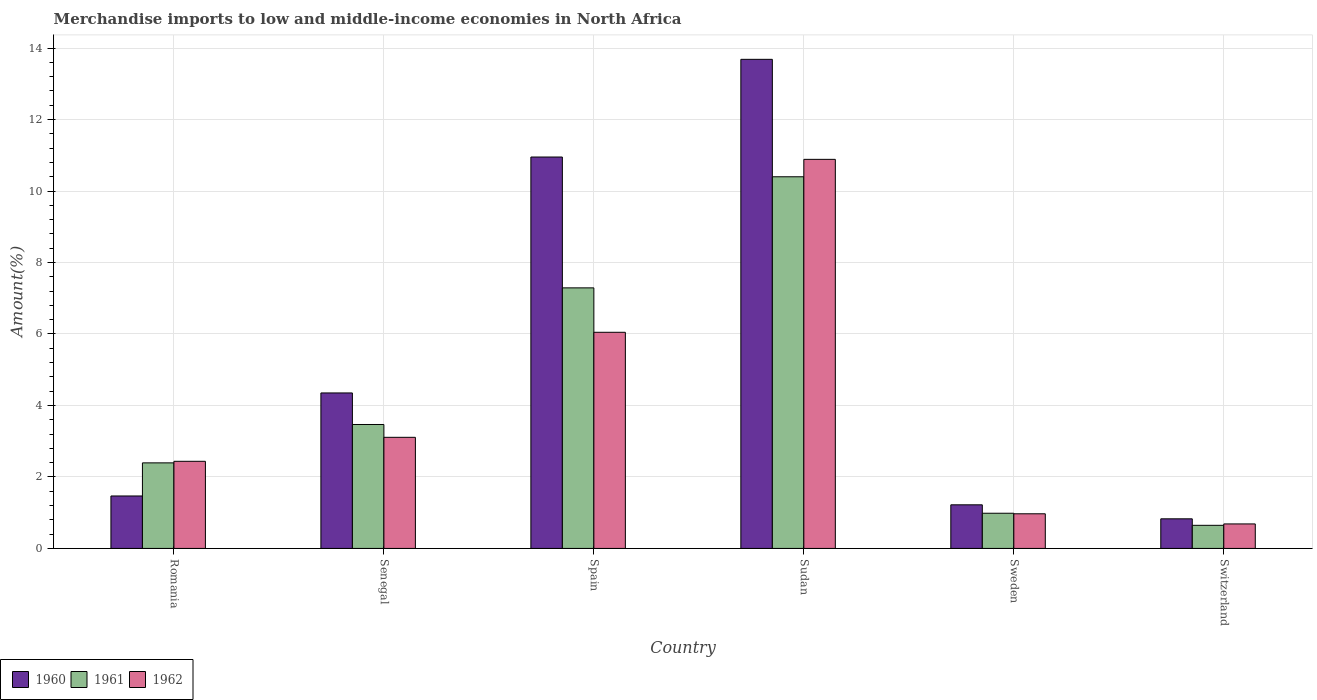Are the number of bars per tick equal to the number of legend labels?
Offer a terse response. Yes. Are the number of bars on each tick of the X-axis equal?
Your answer should be very brief. Yes. How many bars are there on the 4th tick from the left?
Provide a short and direct response. 3. What is the label of the 6th group of bars from the left?
Offer a very short reply. Switzerland. In how many cases, is the number of bars for a given country not equal to the number of legend labels?
Provide a short and direct response. 0. What is the percentage of amount earned from merchandise imports in 1962 in Senegal?
Your answer should be very brief. 3.11. Across all countries, what is the maximum percentage of amount earned from merchandise imports in 1962?
Provide a succinct answer. 10.89. Across all countries, what is the minimum percentage of amount earned from merchandise imports in 1961?
Offer a very short reply. 0.65. In which country was the percentage of amount earned from merchandise imports in 1962 maximum?
Give a very brief answer. Sudan. In which country was the percentage of amount earned from merchandise imports in 1960 minimum?
Offer a terse response. Switzerland. What is the total percentage of amount earned from merchandise imports in 1960 in the graph?
Offer a very short reply. 32.5. What is the difference between the percentage of amount earned from merchandise imports in 1962 in Senegal and that in Sweden?
Your answer should be compact. 2.14. What is the difference between the percentage of amount earned from merchandise imports in 1960 in Sweden and the percentage of amount earned from merchandise imports in 1961 in Senegal?
Your response must be concise. -2.25. What is the average percentage of amount earned from merchandise imports in 1961 per country?
Keep it short and to the point. 4.2. What is the difference between the percentage of amount earned from merchandise imports of/in 1962 and percentage of amount earned from merchandise imports of/in 1960 in Switzerland?
Give a very brief answer. -0.14. What is the ratio of the percentage of amount earned from merchandise imports in 1962 in Romania to that in Senegal?
Offer a very short reply. 0.78. Is the difference between the percentage of amount earned from merchandise imports in 1962 in Romania and Switzerland greater than the difference between the percentage of amount earned from merchandise imports in 1960 in Romania and Switzerland?
Give a very brief answer. Yes. What is the difference between the highest and the second highest percentage of amount earned from merchandise imports in 1962?
Offer a terse response. 7.78. What is the difference between the highest and the lowest percentage of amount earned from merchandise imports in 1961?
Give a very brief answer. 9.75. In how many countries, is the percentage of amount earned from merchandise imports in 1961 greater than the average percentage of amount earned from merchandise imports in 1961 taken over all countries?
Give a very brief answer. 2. How many bars are there?
Your response must be concise. 18. Are all the bars in the graph horizontal?
Offer a terse response. No. What is the difference between two consecutive major ticks on the Y-axis?
Give a very brief answer. 2. Does the graph contain grids?
Offer a terse response. Yes. How are the legend labels stacked?
Ensure brevity in your answer.  Horizontal. What is the title of the graph?
Provide a succinct answer. Merchandise imports to low and middle-income economies in North Africa. Does "1976" appear as one of the legend labels in the graph?
Offer a very short reply. No. What is the label or title of the Y-axis?
Your answer should be compact. Amount(%). What is the Amount(%) in 1960 in Romania?
Make the answer very short. 1.47. What is the Amount(%) in 1961 in Romania?
Give a very brief answer. 2.39. What is the Amount(%) of 1962 in Romania?
Offer a very short reply. 2.44. What is the Amount(%) of 1960 in Senegal?
Ensure brevity in your answer.  4.35. What is the Amount(%) of 1961 in Senegal?
Ensure brevity in your answer.  3.47. What is the Amount(%) of 1962 in Senegal?
Ensure brevity in your answer.  3.11. What is the Amount(%) of 1960 in Spain?
Keep it short and to the point. 10.95. What is the Amount(%) of 1961 in Spain?
Your response must be concise. 7.29. What is the Amount(%) of 1962 in Spain?
Keep it short and to the point. 6.05. What is the Amount(%) in 1960 in Sudan?
Your response must be concise. 13.68. What is the Amount(%) in 1961 in Sudan?
Your answer should be compact. 10.4. What is the Amount(%) in 1962 in Sudan?
Offer a terse response. 10.89. What is the Amount(%) of 1960 in Sweden?
Keep it short and to the point. 1.22. What is the Amount(%) in 1961 in Sweden?
Make the answer very short. 0.98. What is the Amount(%) in 1962 in Sweden?
Offer a terse response. 0.97. What is the Amount(%) in 1960 in Switzerland?
Provide a short and direct response. 0.83. What is the Amount(%) of 1961 in Switzerland?
Ensure brevity in your answer.  0.65. What is the Amount(%) of 1962 in Switzerland?
Keep it short and to the point. 0.69. Across all countries, what is the maximum Amount(%) in 1960?
Your response must be concise. 13.68. Across all countries, what is the maximum Amount(%) of 1961?
Your response must be concise. 10.4. Across all countries, what is the maximum Amount(%) of 1962?
Offer a very short reply. 10.89. Across all countries, what is the minimum Amount(%) in 1960?
Give a very brief answer. 0.83. Across all countries, what is the minimum Amount(%) of 1961?
Offer a very short reply. 0.65. Across all countries, what is the minimum Amount(%) of 1962?
Keep it short and to the point. 0.69. What is the total Amount(%) in 1960 in the graph?
Offer a terse response. 32.5. What is the total Amount(%) in 1961 in the graph?
Your response must be concise. 25.18. What is the total Amount(%) of 1962 in the graph?
Provide a succinct answer. 24.13. What is the difference between the Amount(%) of 1960 in Romania and that in Senegal?
Your answer should be very brief. -2.88. What is the difference between the Amount(%) in 1961 in Romania and that in Senegal?
Your response must be concise. -1.07. What is the difference between the Amount(%) in 1962 in Romania and that in Senegal?
Offer a terse response. -0.67. What is the difference between the Amount(%) of 1960 in Romania and that in Spain?
Offer a very short reply. -9.48. What is the difference between the Amount(%) of 1961 in Romania and that in Spain?
Provide a short and direct response. -4.9. What is the difference between the Amount(%) in 1962 in Romania and that in Spain?
Your answer should be compact. -3.61. What is the difference between the Amount(%) of 1960 in Romania and that in Sudan?
Make the answer very short. -12.22. What is the difference between the Amount(%) of 1961 in Romania and that in Sudan?
Provide a succinct answer. -8. What is the difference between the Amount(%) in 1962 in Romania and that in Sudan?
Ensure brevity in your answer.  -8.45. What is the difference between the Amount(%) of 1960 in Romania and that in Sweden?
Make the answer very short. 0.25. What is the difference between the Amount(%) of 1961 in Romania and that in Sweden?
Ensure brevity in your answer.  1.41. What is the difference between the Amount(%) in 1962 in Romania and that in Sweden?
Your response must be concise. 1.47. What is the difference between the Amount(%) in 1960 in Romania and that in Switzerland?
Ensure brevity in your answer.  0.64. What is the difference between the Amount(%) of 1961 in Romania and that in Switzerland?
Offer a very short reply. 1.75. What is the difference between the Amount(%) of 1962 in Romania and that in Switzerland?
Offer a very short reply. 1.75. What is the difference between the Amount(%) of 1960 in Senegal and that in Spain?
Your answer should be compact. -6.6. What is the difference between the Amount(%) of 1961 in Senegal and that in Spain?
Offer a terse response. -3.82. What is the difference between the Amount(%) in 1962 in Senegal and that in Spain?
Your response must be concise. -2.94. What is the difference between the Amount(%) of 1960 in Senegal and that in Sudan?
Your answer should be very brief. -9.33. What is the difference between the Amount(%) in 1961 in Senegal and that in Sudan?
Give a very brief answer. -6.93. What is the difference between the Amount(%) in 1962 in Senegal and that in Sudan?
Your answer should be compact. -7.78. What is the difference between the Amount(%) in 1960 in Senegal and that in Sweden?
Your answer should be compact. 3.13. What is the difference between the Amount(%) of 1961 in Senegal and that in Sweden?
Ensure brevity in your answer.  2.48. What is the difference between the Amount(%) of 1962 in Senegal and that in Sweden?
Your answer should be very brief. 2.14. What is the difference between the Amount(%) in 1960 in Senegal and that in Switzerland?
Offer a very short reply. 3.52. What is the difference between the Amount(%) of 1961 in Senegal and that in Switzerland?
Offer a very short reply. 2.82. What is the difference between the Amount(%) in 1962 in Senegal and that in Switzerland?
Your answer should be compact. 2.42. What is the difference between the Amount(%) in 1960 in Spain and that in Sudan?
Provide a succinct answer. -2.73. What is the difference between the Amount(%) in 1961 in Spain and that in Sudan?
Your answer should be compact. -3.11. What is the difference between the Amount(%) of 1962 in Spain and that in Sudan?
Keep it short and to the point. -4.84. What is the difference between the Amount(%) in 1960 in Spain and that in Sweden?
Provide a short and direct response. 9.73. What is the difference between the Amount(%) of 1961 in Spain and that in Sweden?
Offer a terse response. 6.31. What is the difference between the Amount(%) of 1962 in Spain and that in Sweden?
Make the answer very short. 5.08. What is the difference between the Amount(%) of 1960 in Spain and that in Switzerland?
Your answer should be very brief. 10.12. What is the difference between the Amount(%) of 1961 in Spain and that in Switzerland?
Your answer should be very brief. 6.64. What is the difference between the Amount(%) of 1962 in Spain and that in Switzerland?
Ensure brevity in your answer.  5.36. What is the difference between the Amount(%) in 1960 in Sudan and that in Sweden?
Offer a terse response. 12.46. What is the difference between the Amount(%) in 1961 in Sudan and that in Sweden?
Provide a short and direct response. 9.41. What is the difference between the Amount(%) of 1962 in Sudan and that in Sweden?
Your answer should be very brief. 9.92. What is the difference between the Amount(%) in 1960 in Sudan and that in Switzerland?
Offer a terse response. 12.86. What is the difference between the Amount(%) in 1961 in Sudan and that in Switzerland?
Provide a succinct answer. 9.75. What is the difference between the Amount(%) in 1962 in Sudan and that in Switzerland?
Provide a short and direct response. 10.2. What is the difference between the Amount(%) of 1960 in Sweden and that in Switzerland?
Your answer should be very brief. 0.39. What is the difference between the Amount(%) in 1961 in Sweden and that in Switzerland?
Provide a succinct answer. 0.34. What is the difference between the Amount(%) in 1962 in Sweden and that in Switzerland?
Ensure brevity in your answer.  0.28. What is the difference between the Amount(%) in 1960 in Romania and the Amount(%) in 1961 in Senegal?
Your answer should be very brief. -2. What is the difference between the Amount(%) of 1960 in Romania and the Amount(%) of 1962 in Senegal?
Offer a very short reply. -1.64. What is the difference between the Amount(%) in 1961 in Romania and the Amount(%) in 1962 in Senegal?
Make the answer very short. -0.71. What is the difference between the Amount(%) of 1960 in Romania and the Amount(%) of 1961 in Spain?
Your response must be concise. -5.82. What is the difference between the Amount(%) of 1960 in Romania and the Amount(%) of 1962 in Spain?
Ensure brevity in your answer.  -4.58. What is the difference between the Amount(%) in 1961 in Romania and the Amount(%) in 1962 in Spain?
Your answer should be very brief. -3.65. What is the difference between the Amount(%) of 1960 in Romania and the Amount(%) of 1961 in Sudan?
Your answer should be very brief. -8.93. What is the difference between the Amount(%) in 1960 in Romania and the Amount(%) in 1962 in Sudan?
Offer a very short reply. -9.42. What is the difference between the Amount(%) of 1961 in Romania and the Amount(%) of 1962 in Sudan?
Keep it short and to the point. -8.49. What is the difference between the Amount(%) in 1960 in Romania and the Amount(%) in 1961 in Sweden?
Offer a terse response. 0.48. What is the difference between the Amount(%) of 1960 in Romania and the Amount(%) of 1962 in Sweden?
Make the answer very short. 0.5. What is the difference between the Amount(%) of 1961 in Romania and the Amount(%) of 1962 in Sweden?
Offer a very short reply. 1.42. What is the difference between the Amount(%) of 1960 in Romania and the Amount(%) of 1961 in Switzerland?
Make the answer very short. 0.82. What is the difference between the Amount(%) of 1960 in Romania and the Amount(%) of 1962 in Switzerland?
Your answer should be very brief. 0.78. What is the difference between the Amount(%) in 1961 in Romania and the Amount(%) in 1962 in Switzerland?
Give a very brief answer. 1.71. What is the difference between the Amount(%) in 1960 in Senegal and the Amount(%) in 1961 in Spain?
Offer a very short reply. -2.94. What is the difference between the Amount(%) of 1960 in Senegal and the Amount(%) of 1962 in Spain?
Provide a short and direct response. -1.7. What is the difference between the Amount(%) of 1961 in Senegal and the Amount(%) of 1962 in Spain?
Make the answer very short. -2.58. What is the difference between the Amount(%) in 1960 in Senegal and the Amount(%) in 1961 in Sudan?
Ensure brevity in your answer.  -6.05. What is the difference between the Amount(%) in 1960 in Senegal and the Amount(%) in 1962 in Sudan?
Your response must be concise. -6.54. What is the difference between the Amount(%) of 1961 in Senegal and the Amount(%) of 1962 in Sudan?
Make the answer very short. -7.42. What is the difference between the Amount(%) of 1960 in Senegal and the Amount(%) of 1961 in Sweden?
Make the answer very short. 3.37. What is the difference between the Amount(%) in 1960 in Senegal and the Amount(%) in 1962 in Sweden?
Give a very brief answer. 3.38. What is the difference between the Amount(%) of 1961 in Senegal and the Amount(%) of 1962 in Sweden?
Keep it short and to the point. 2.5. What is the difference between the Amount(%) of 1960 in Senegal and the Amount(%) of 1961 in Switzerland?
Make the answer very short. 3.7. What is the difference between the Amount(%) of 1960 in Senegal and the Amount(%) of 1962 in Switzerland?
Make the answer very short. 3.66. What is the difference between the Amount(%) in 1961 in Senegal and the Amount(%) in 1962 in Switzerland?
Make the answer very short. 2.78. What is the difference between the Amount(%) in 1960 in Spain and the Amount(%) in 1961 in Sudan?
Offer a terse response. 0.55. What is the difference between the Amount(%) of 1960 in Spain and the Amount(%) of 1962 in Sudan?
Keep it short and to the point. 0.07. What is the difference between the Amount(%) in 1961 in Spain and the Amount(%) in 1962 in Sudan?
Ensure brevity in your answer.  -3.6. What is the difference between the Amount(%) in 1960 in Spain and the Amount(%) in 1961 in Sweden?
Provide a succinct answer. 9.97. What is the difference between the Amount(%) of 1960 in Spain and the Amount(%) of 1962 in Sweden?
Give a very brief answer. 9.98. What is the difference between the Amount(%) in 1961 in Spain and the Amount(%) in 1962 in Sweden?
Offer a very short reply. 6.32. What is the difference between the Amount(%) in 1960 in Spain and the Amount(%) in 1961 in Switzerland?
Provide a succinct answer. 10.3. What is the difference between the Amount(%) in 1960 in Spain and the Amount(%) in 1962 in Switzerland?
Your answer should be very brief. 10.27. What is the difference between the Amount(%) in 1961 in Spain and the Amount(%) in 1962 in Switzerland?
Give a very brief answer. 6.6. What is the difference between the Amount(%) of 1960 in Sudan and the Amount(%) of 1961 in Sweden?
Provide a succinct answer. 12.7. What is the difference between the Amount(%) in 1960 in Sudan and the Amount(%) in 1962 in Sweden?
Your answer should be very brief. 12.71. What is the difference between the Amount(%) of 1961 in Sudan and the Amount(%) of 1962 in Sweden?
Ensure brevity in your answer.  9.43. What is the difference between the Amount(%) in 1960 in Sudan and the Amount(%) in 1961 in Switzerland?
Provide a succinct answer. 13.04. What is the difference between the Amount(%) in 1960 in Sudan and the Amount(%) in 1962 in Switzerland?
Provide a short and direct response. 13. What is the difference between the Amount(%) in 1961 in Sudan and the Amount(%) in 1962 in Switzerland?
Provide a succinct answer. 9.71. What is the difference between the Amount(%) of 1960 in Sweden and the Amount(%) of 1961 in Switzerland?
Your response must be concise. 0.57. What is the difference between the Amount(%) of 1960 in Sweden and the Amount(%) of 1962 in Switzerland?
Offer a very short reply. 0.53. What is the difference between the Amount(%) in 1961 in Sweden and the Amount(%) in 1962 in Switzerland?
Offer a terse response. 0.3. What is the average Amount(%) of 1960 per country?
Your answer should be compact. 5.42. What is the average Amount(%) of 1961 per country?
Ensure brevity in your answer.  4.2. What is the average Amount(%) in 1962 per country?
Make the answer very short. 4.02. What is the difference between the Amount(%) of 1960 and Amount(%) of 1961 in Romania?
Offer a terse response. -0.93. What is the difference between the Amount(%) of 1960 and Amount(%) of 1962 in Romania?
Provide a short and direct response. -0.97. What is the difference between the Amount(%) in 1961 and Amount(%) in 1962 in Romania?
Make the answer very short. -0.04. What is the difference between the Amount(%) in 1960 and Amount(%) in 1961 in Senegal?
Give a very brief answer. 0.88. What is the difference between the Amount(%) of 1960 and Amount(%) of 1962 in Senegal?
Ensure brevity in your answer.  1.24. What is the difference between the Amount(%) of 1961 and Amount(%) of 1962 in Senegal?
Provide a short and direct response. 0.36. What is the difference between the Amount(%) in 1960 and Amount(%) in 1961 in Spain?
Ensure brevity in your answer.  3.66. What is the difference between the Amount(%) in 1960 and Amount(%) in 1962 in Spain?
Make the answer very short. 4.9. What is the difference between the Amount(%) in 1961 and Amount(%) in 1962 in Spain?
Ensure brevity in your answer.  1.24. What is the difference between the Amount(%) of 1960 and Amount(%) of 1961 in Sudan?
Offer a terse response. 3.29. What is the difference between the Amount(%) in 1960 and Amount(%) in 1962 in Sudan?
Provide a succinct answer. 2.8. What is the difference between the Amount(%) in 1961 and Amount(%) in 1962 in Sudan?
Your answer should be compact. -0.49. What is the difference between the Amount(%) in 1960 and Amount(%) in 1961 in Sweden?
Offer a very short reply. 0.24. What is the difference between the Amount(%) of 1960 and Amount(%) of 1962 in Sweden?
Give a very brief answer. 0.25. What is the difference between the Amount(%) in 1961 and Amount(%) in 1962 in Sweden?
Your response must be concise. 0.02. What is the difference between the Amount(%) in 1960 and Amount(%) in 1961 in Switzerland?
Provide a succinct answer. 0.18. What is the difference between the Amount(%) in 1960 and Amount(%) in 1962 in Switzerland?
Offer a terse response. 0.14. What is the difference between the Amount(%) of 1961 and Amount(%) of 1962 in Switzerland?
Provide a succinct answer. -0.04. What is the ratio of the Amount(%) of 1960 in Romania to that in Senegal?
Ensure brevity in your answer.  0.34. What is the ratio of the Amount(%) in 1961 in Romania to that in Senegal?
Your response must be concise. 0.69. What is the ratio of the Amount(%) in 1962 in Romania to that in Senegal?
Offer a terse response. 0.78. What is the ratio of the Amount(%) of 1960 in Romania to that in Spain?
Your answer should be very brief. 0.13. What is the ratio of the Amount(%) in 1961 in Romania to that in Spain?
Your response must be concise. 0.33. What is the ratio of the Amount(%) of 1962 in Romania to that in Spain?
Give a very brief answer. 0.4. What is the ratio of the Amount(%) in 1960 in Romania to that in Sudan?
Offer a very short reply. 0.11. What is the ratio of the Amount(%) of 1961 in Romania to that in Sudan?
Offer a very short reply. 0.23. What is the ratio of the Amount(%) in 1962 in Romania to that in Sudan?
Give a very brief answer. 0.22. What is the ratio of the Amount(%) of 1960 in Romania to that in Sweden?
Provide a succinct answer. 1.2. What is the ratio of the Amount(%) in 1961 in Romania to that in Sweden?
Your answer should be very brief. 2.43. What is the ratio of the Amount(%) of 1962 in Romania to that in Sweden?
Ensure brevity in your answer.  2.51. What is the ratio of the Amount(%) in 1960 in Romania to that in Switzerland?
Offer a terse response. 1.77. What is the ratio of the Amount(%) of 1961 in Romania to that in Switzerland?
Ensure brevity in your answer.  3.7. What is the ratio of the Amount(%) of 1962 in Romania to that in Switzerland?
Provide a short and direct response. 3.55. What is the ratio of the Amount(%) in 1960 in Senegal to that in Spain?
Make the answer very short. 0.4. What is the ratio of the Amount(%) in 1961 in Senegal to that in Spain?
Offer a terse response. 0.48. What is the ratio of the Amount(%) of 1962 in Senegal to that in Spain?
Keep it short and to the point. 0.51. What is the ratio of the Amount(%) of 1960 in Senegal to that in Sudan?
Provide a succinct answer. 0.32. What is the ratio of the Amount(%) in 1961 in Senegal to that in Sudan?
Offer a very short reply. 0.33. What is the ratio of the Amount(%) of 1962 in Senegal to that in Sudan?
Offer a very short reply. 0.29. What is the ratio of the Amount(%) of 1960 in Senegal to that in Sweden?
Your response must be concise. 3.57. What is the ratio of the Amount(%) of 1961 in Senegal to that in Sweden?
Keep it short and to the point. 3.52. What is the ratio of the Amount(%) of 1962 in Senegal to that in Sweden?
Offer a terse response. 3.21. What is the ratio of the Amount(%) of 1960 in Senegal to that in Switzerland?
Give a very brief answer. 5.25. What is the ratio of the Amount(%) in 1961 in Senegal to that in Switzerland?
Your answer should be compact. 5.36. What is the ratio of the Amount(%) in 1962 in Senegal to that in Switzerland?
Make the answer very short. 4.53. What is the ratio of the Amount(%) in 1960 in Spain to that in Sudan?
Give a very brief answer. 0.8. What is the ratio of the Amount(%) in 1961 in Spain to that in Sudan?
Provide a short and direct response. 0.7. What is the ratio of the Amount(%) of 1962 in Spain to that in Sudan?
Give a very brief answer. 0.56. What is the ratio of the Amount(%) of 1960 in Spain to that in Sweden?
Make the answer very short. 8.97. What is the ratio of the Amount(%) of 1961 in Spain to that in Sweden?
Give a very brief answer. 7.4. What is the ratio of the Amount(%) of 1962 in Spain to that in Sweden?
Make the answer very short. 6.24. What is the ratio of the Amount(%) in 1960 in Spain to that in Switzerland?
Your answer should be very brief. 13.22. What is the ratio of the Amount(%) of 1961 in Spain to that in Switzerland?
Your response must be concise. 11.28. What is the ratio of the Amount(%) of 1962 in Spain to that in Switzerland?
Your answer should be very brief. 8.82. What is the ratio of the Amount(%) of 1960 in Sudan to that in Sweden?
Your answer should be very brief. 11.21. What is the ratio of the Amount(%) in 1961 in Sudan to that in Sweden?
Offer a terse response. 10.56. What is the ratio of the Amount(%) of 1962 in Sudan to that in Sweden?
Ensure brevity in your answer.  11.23. What is the ratio of the Amount(%) in 1960 in Sudan to that in Switzerland?
Ensure brevity in your answer.  16.52. What is the ratio of the Amount(%) of 1961 in Sudan to that in Switzerland?
Your answer should be compact. 16.08. What is the ratio of the Amount(%) of 1962 in Sudan to that in Switzerland?
Provide a succinct answer. 15.87. What is the ratio of the Amount(%) of 1960 in Sweden to that in Switzerland?
Your answer should be very brief. 1.47. What is the ratio of the Amount(%) in 1961 in Sweden to that in Switzerland?
Provide a short and direct response. 1.52. What is the ratio of the Amount(%) of 1962 in Sweden to that in Switzerland?
Your answer should be compact. 1.41. What is the difference between the highest and the second highest Amount(%) of 1960?
Your answer should be very brief. 2.73. What is the difference between the highest and the second highest Amount(%) of 1961?
Keep it short and to the point. 3.11. What is the difference between the highest and the second highest Amount(%) of 1962?
Provide a succinct answer. 4.84. What is the difference between the highest and the lowest Amount(%) in 1960?
Provide a succinct answer. 12.86. What is the difference between the highest and the lowest Amount(%) in 1961?
Provide a short and direct response. 9.75. What is the difference between the highest and the lowest Amount(%) in 1962?
Your answer should be compact. 10.2. 